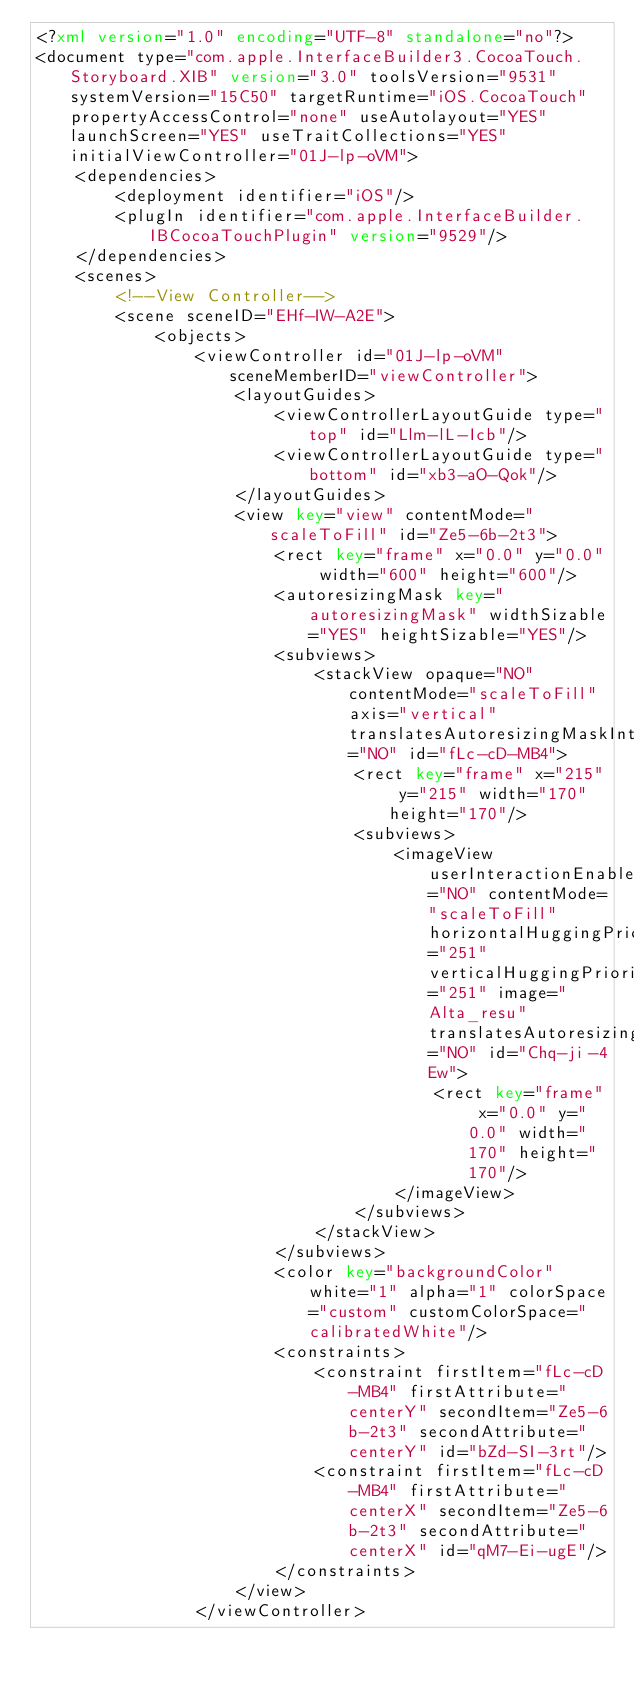<code> <loc_0><loc_0><loc_500><loc_500><_XML_><?xml version="1.0" encoding="UTF-8" standalone="no"?>
<document type="com.apple.InterfaceBuilder3.CocoaTouch.Storyboard.XIB" version="3.0" toolsVersion="9531" systemVersion="15C50" targetRuntime="iOS.CocoaTouch" propertyAccessControl="none" useAutolayout="YES" launchScreen="YES" useTraitCollections="YES" initialViewController="01J-lp-oVM">
    <dependencies>
        <deployment identifier="iOS"/>
        <plugIn identifier="com.apple.InterfaceBuilder.IBCocoaTouchPlugin" version="9529"/>
    </dependencies>
    <scenes>
        <!--View Controller-->
        <scene sceneID="EHf-IW-A2E">
            <objects>
                <viewController id="01J-lp-oVM" sceneMemberID="viewController">
                    <layoutGuides>
                        <viewControllerLayoutGuide type="top" id="Llm-lL-Icb"/>
                        <viewControllerLayoutGuide type="bottom" id="xb3-aO-Qok"/>
                    </layoutGuides>
                    <view key="view" contentMode="scaleToFill" id="Ze5-6b-2t3">
                        <rect key="frame" x="0.0" y="0.0" width="600" height="600"/>
                        <autoresizingMask key="autoresizingMask" widthSizable="YES" heightSizable="YES"/>
                        <subviews>
                            <stackView opaque="NO" contentMode="scaleToFill" axis="vertical" translatesAutoresizingMaskIntoConstraints="NO" id="fLc-cD-MB4">
                                <rect key="frame" x="215" y="215" width="170" height="170"/>
                                <subviews>
                                    <imageView userInteractionEnabled="NO" contentMode="scaleToFill" horizontalHuggingPriority="251" verticalHuggingPriority="251" image="Alta_resu" translatesAutoresizingMaskIntoConstraints="NO" id="Chq-ji-4Ew">
                                        <rect key="frame" x="0.0" y="0.0" width="170" height="170"/>
                                    </imageView>
                                </subviews>
                            </stackView>
                        </subviews>
                        <color key="backgroundColor" white="1" alpha="1" colorSpace="custom" customColorSpace="calibratedWhite"/>
                        <constraints>
                            <constraint firstItem="fLc-cD-MB4" firstAttribute="centerY" secondItem="Ze5-6b-2t3" secondAttribute="centerY" id="bZd-SI-3rt"/>
                            <constraint firstItem="fLc-cD-MB4" firstAttribute="centerX" secondItem="Ze5-6b-2t3" secondAttribute="centerX" id="qM7-Ei-ugE"/>
                        </constraints>
                    </view>
                </viewController></code> 